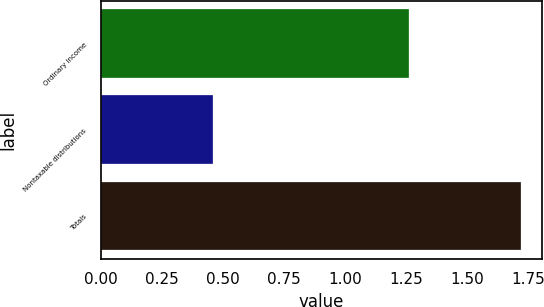Convert chart. <chart><loc_0><loc_0><loc_500><loc_500><bar_chart><fcel>Ordinary income<fcel>Nontaxable distributions<fcel>Totals<nl><fcel>1.26<fcel>0.46<fcel>1.72<nl></chart> 